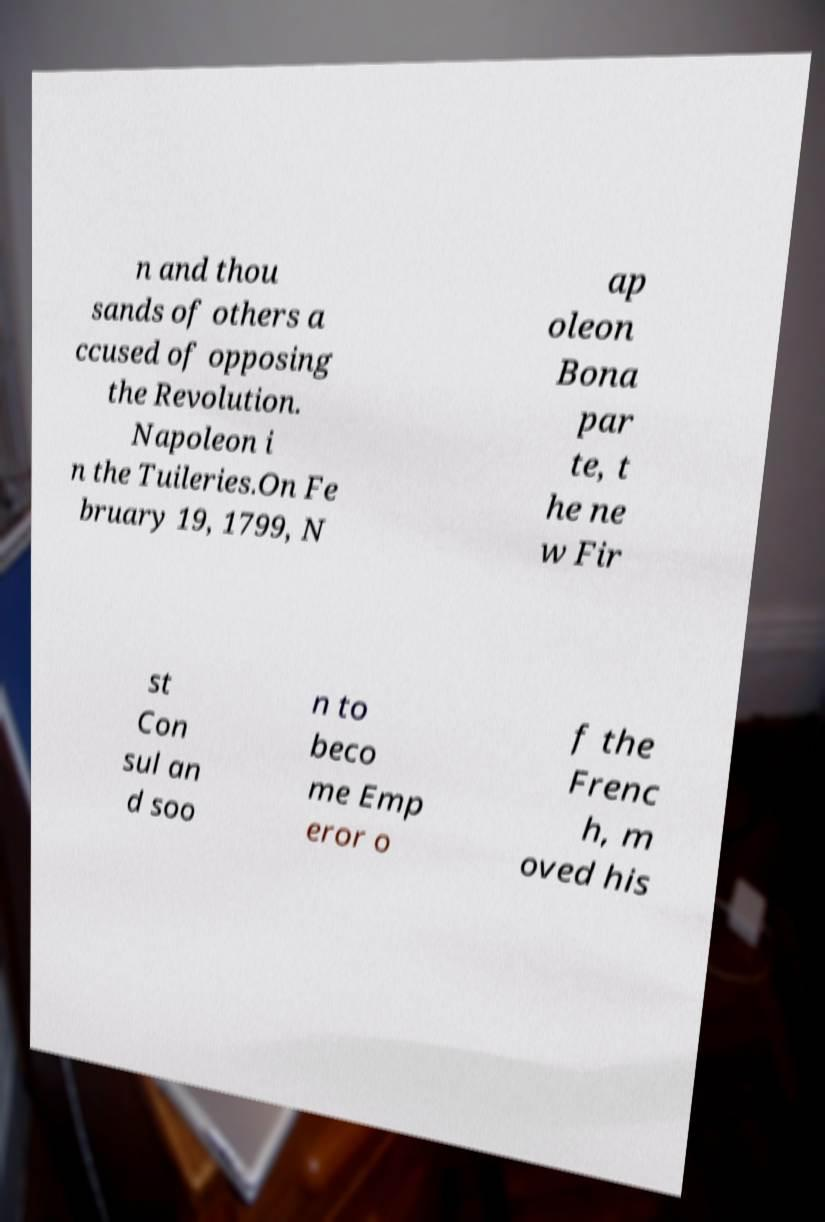I need the written content from this picture converted into text. Can you do that? n and thou sands of others a ccused of opposing the Revolution. Napoleon i n the Tuileries.On Fe bruary 19, 1799, N ap oleon Bona par te, t he ne w Fir st Con sul an d soo n to beco me Emp eror o f the Frenc h, m oved his 